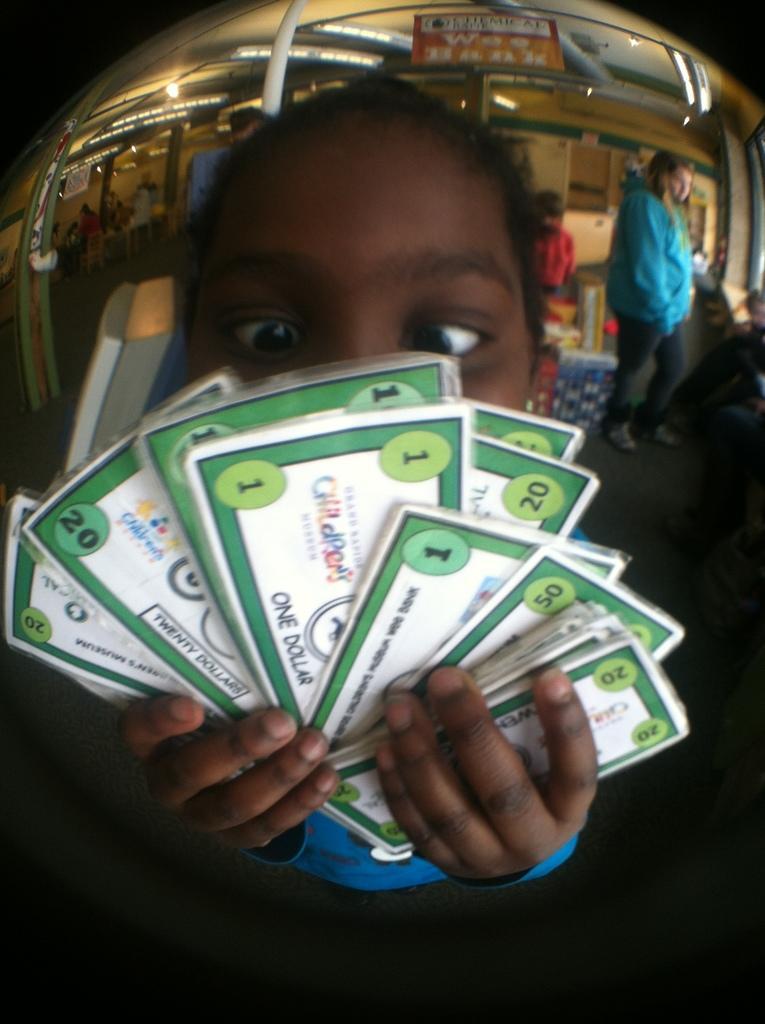Could you give a brief overview of what you see in this image? In this image in the foreground a person holding some cash and in the background we can see some people. 